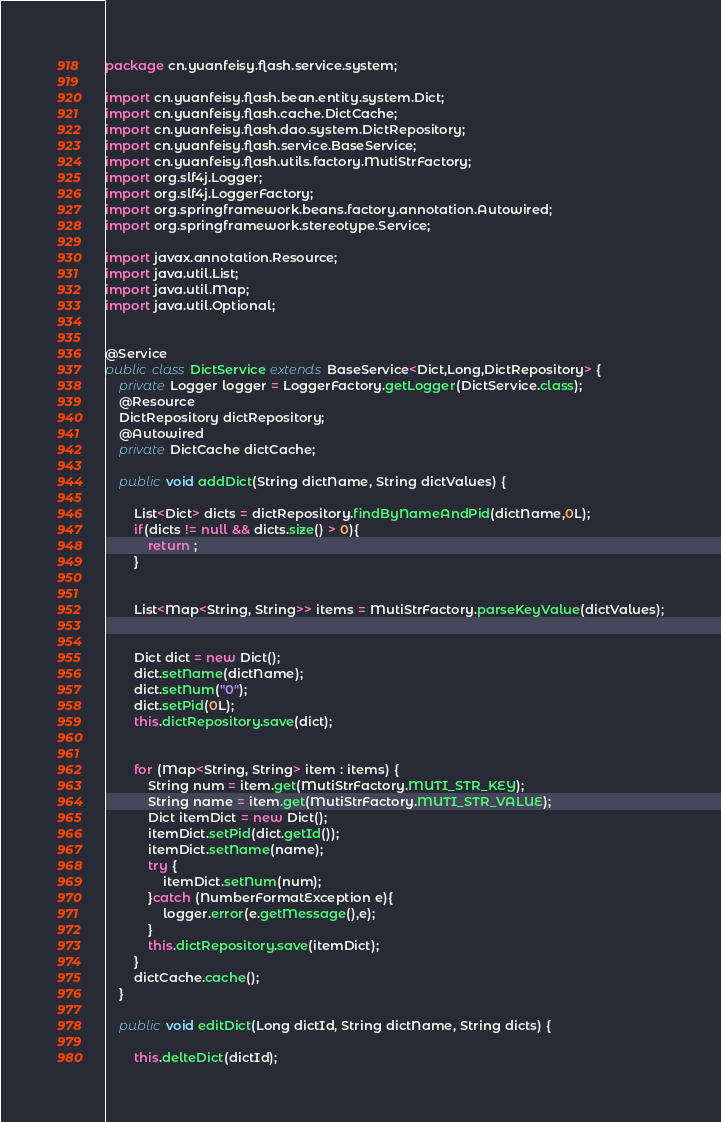<code> <loc_0><loc_0><loc_500><loc_500><_Java_>package cn.yuanfeisy.flash.service.system;

import cn.yuanfeisy.flash.bean.entity.system.Dict;
import cn.yuanfeisy.flash.cache.DictCache;
import cn.yuanfeisy.flash.dao.system.DictRepository;
import cn.yuanfeisy.flash.service.BaseService;
import cn.yuanfeisy.flash.utils.factory.MutiStrFactory;
import org.slf4j.Logger;
import org.slf4j.LoggerFactory;
import org.springframework.beans.factory.annotation.Autowired;
import org.springframework.stereotype.Service;

import javax.annotation.Resource;
import java.util.List;
import java.util.Map;
import java.util.Optional;


@Service
public class DictService extends BaseService<Dict,Long,DictRepository> {
    private Logger logger = LoggerFactory.getLogger(DictService.class);
    @Resource
    DictRepository dictRepository;
    @Autowired
    private DictCache dictCache;

    public void addDict(String dictName, String dictValues) {

        List<Dict> dicts = dictRepository.findByNameAndPid(dictName,0L);
        if(dicts != null && dicts.size() > 0){
            return ;
        }


        List<Map<String, String>> items = MutiStrFactory.parseKeyValue(dictValues);


        Dict dict = new Dict();
        dict.setName(dictName);
        dict.setNum("0");
        dict.setPid(0L);
        this.dictRepository.save(dict);


        for (Map<String, String> item : items) {
            String num = item.get(MutiStrFactory.MUTI_STR_KEY);
            String name = item.get(MutiStrFactory.MUTI_STR_VALUE);
            Dict itemDict = new Dict();
            itemDict.setPid(dict.getId());
            itemDict.setName(name);
            try {
                itemDict.setNum(num);
            }catch (NumberFormatException e){
                logger.error(e.getMessage(),e);
            }
            this.dictRepository.save(itemDict);
        }
        dictCache.cache();
    }

    public void editDict(Long dictId, String dictName, String dicts) {

        this.delteDict(dictId);

</code> 